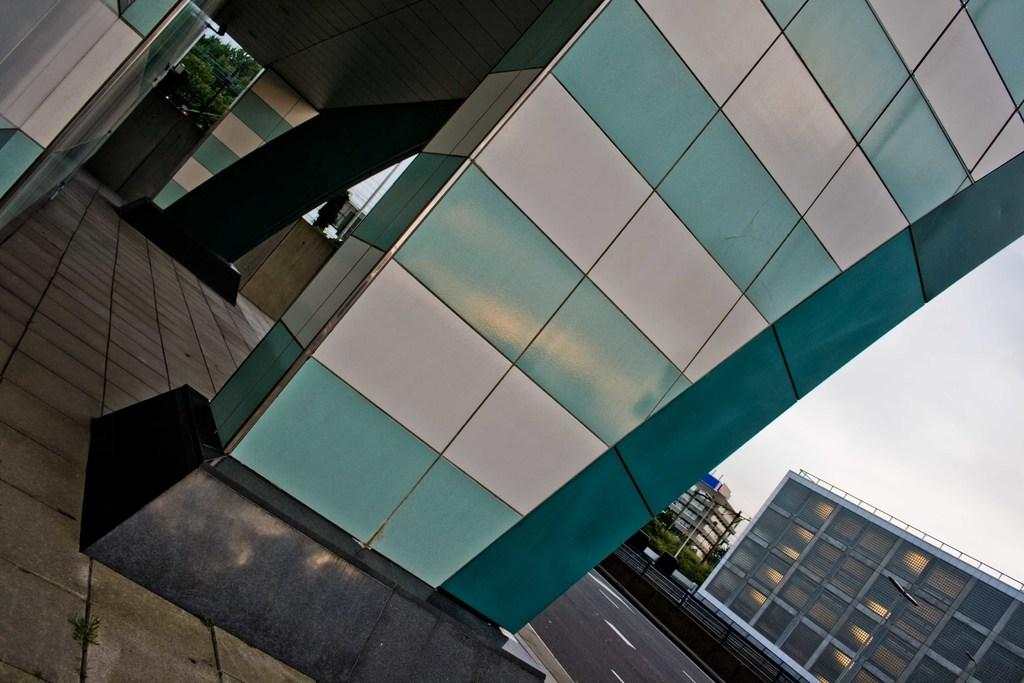What type of building is the main subject of the image? There is a glass building in the image. What can be seen in the background of the image? There are trees and other buildings in the background of the image. What is the color of the trees in the image? The trees in the image are green. What is visible in the sky in the image? The sky is visible in the image and appears to be white. What type of desk can be seen in the image? There is no desk present in the image. What is the reason for the trees being green in the image? The color of the trees is a natural characteristic of trees and not a result of any specific reason in the image. 